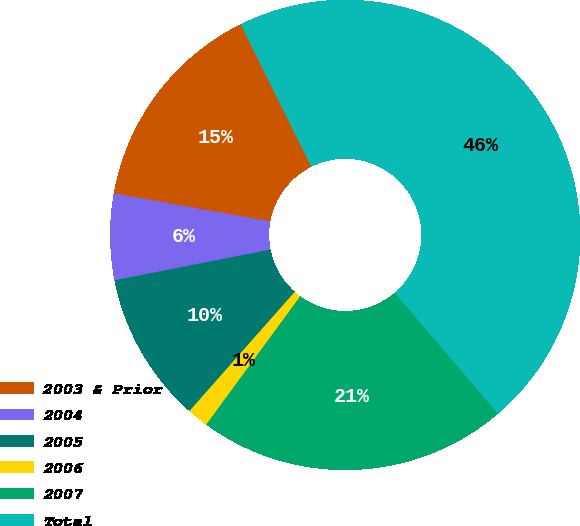<chart> <loc_0><loc_0><loc_500><loc_500><pie_chart><fcel>2003 & Prior<fcel>2004<fcel>2005<fcel>2006<fcel>2007<fcel>Total<nl><fcel>14.84%<fcel>5.92%<fcel>10.38%<fcel>1.46%<fcel>21.32%<fcel>46.07%<nl></chart> 